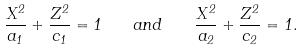<formula> <loc_0><loc_0><loc_500><loc_500>\frac { X ^ { 2 } } { a _ { 1 } } + \frac { Z ^ { 2 } } { c _ { 1 } } = 1 \quad a n d \quad \frac { X ^ { 2 } } { a _ { 2 } } + \frac { Z ^ { 2 } } { c _ { 2 } } = 1 .</formula> 